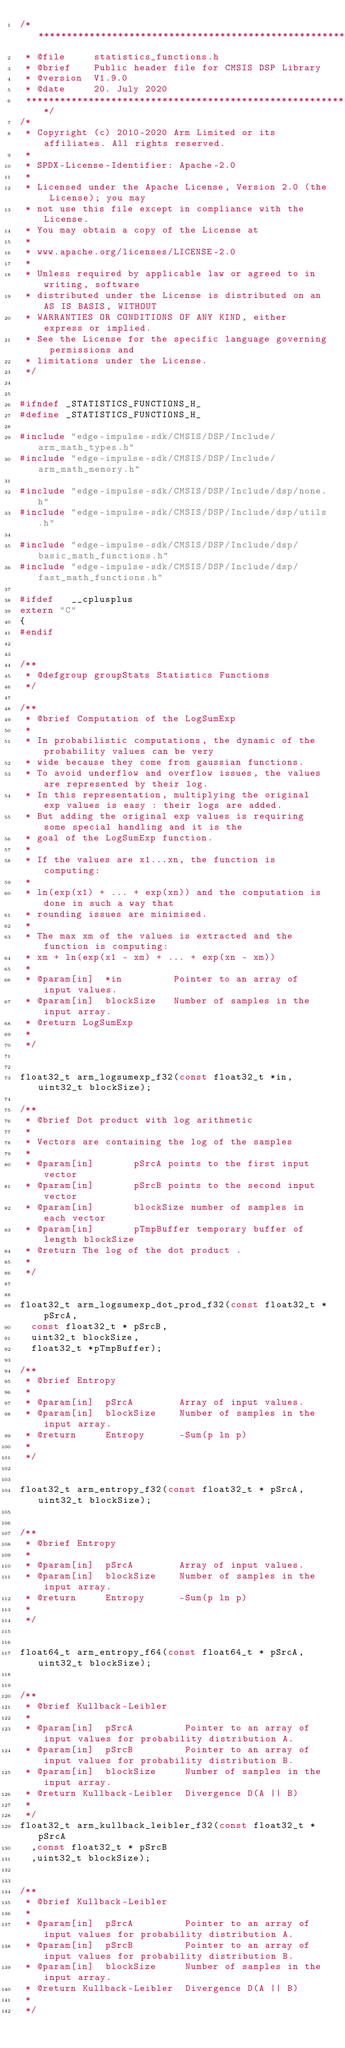Convert code to text. <code><loc_0><loc_0><loc_500><loc_500><_C_>/******************************************************************************
 * @file     statistics_functions.h
 * @brief    Public header file for CMSIS DSP Library
 * @version  V1.9.0
 * @date     20. July 2020
 ******************************************************************************/
/*
 * Copyright (c) 2010-2020 Arm Limited or its affiliates. All rights reserved.
 *
 * SPDX-License-Identifier: Apache-2.0
 *
 * Licensed under the Apache License, Version 2.0 (the License); you may
 * not use this file except in compliance with the License.
 * You may obtain a copy of the License at
 *
 * www.apache.org/licenses/LICENSE-2.0
 *
 * Unless required by applicable law or agreed to in writing, software
 * distributed under the License is distributed on an AS IS BASIS, WITHOUT
 * WARRANTIES OR CONDITIONS OF ANY KIND, either express or implied.
 * See the License for the specific language governing permissions and
 * limitations under the License.
 */

 
#ifndef _STATISTICS_FUNCTIONS_H_
#define _STATISTICS_FUNCTIONS_H_

#include "edge-impulse-sdk/CMSIS/DSP/Include/arm_math_types.h"
#include "edge-impulse-sdk/CMSIS/DSP/Include/arm_math_memory.h"

#include "edge-impulse-sdk/CMSIS/DSP/Include/dsp/none.h"
#include "edge-impulse-sdk/CMSIS/DSP/Include/dsp/utils.h"

#include "edge-impulse-sdk/CMSIS/DSP/Include/dsp/basic_math_functions.h"
#include "edge-impulse-sdk/CMSIS/DSP/Include/dsp/fast_math_functions.h"

#ifdef   __cplusplus
extern "C"
{
#endif


/**
 * @defgroup groupStats Statistics Functions
 */

/**
 * @brief Computation of the LogSumExp
 *
 * In probabilistic computations, the dynamic of the probability values can be very
 * wide because they come from gaussian functions.
 * To avoid underflow and overflow issues, the values are represented by their log.
 * In this representation, multiplying the original exp values is easy : their logs are added.
 * But adding the original exp values is requiring some special handling and it is the
 * goal of the LogSumExp function.
 *
 * If the values are x1...xn, the function is computing:
 *
 * ln(exp(x1) + ... + exp(xn)) and the computation is done in such a way that
 * rounding issues are minimised.
 *
 * The max xm of the values is extracted and the function is computing:
 * xm + ln(exp(x1 - xm) + ... + exp(xn - xm))
 *
 * @param[in]  *in         Pointer to an array of input values.
 * @param[in]  blockSize   Number of samples in the input array.
 * @return LogSumExp
 *
 */


float32_t arm_logsumexp_f32(const float32_t *in, uint32_t blockSize);

/**
 * @brief Dot product with log arithmetic
 *
 * Vectors are containing the log of the samples
 *
 * @param[in]       pSrcA points to the first input vector
 * @param[in]       pSrcB points to the second input vector
 * @param[in]       blockSize number of samples in each vector
 * @param[in]       pTmpBuffer temporary buffer of length blockSize
 * @return The log of the dot product .
 *
 */


float32_t arm_logsumexp_dot_prod_f32(const float32_t * pSrcA,
  const float32_t * pSrcB,
  uint32_t blockSize,
  float32_t *pTmpBuffer);

/**
 * @brief Entropy
 *
 * @param[in]  pSrcA        Array of input values.
 * @param[in]  blockSize    Number of samples in the input array.
 * @return     Entropy      -Sum(p ln p)
 *
 */


float32_t arm_entropy_f32(const float32_t * pSrcA,uint32_t blockSize);


/**
 * @brief Entropy
 *
 * @param[in]  pSrcA        Array of input values.
 * @param[in]  blockSize    Number of samples in the input array.
 * @return     Entropy      -Sum(p ln p)
 *
 */


float64_t arm_entropy_f64(const float64_t * pSrcA, uint32_t blockSize);


/**
 * @brief Kullback-Leibler
 *
 * @param[in]  pSrcA         Pointer to an array of input values for probability distribution A.
 * @param[in]  pSrcB         Pointer to an array of input values for probability distribution B.
 * @param[in]  blockSize     Number of samples in the input array.
 * @return Kullback-Leibler  Divergence D(A || B)
 *
 */
float32_t arm_kullback_leibler_f32(const float32_t * pSrcA
  ,const float32_t * pSrcB
  ,uint32_t blockSize);


/**
 * @brief Kullback-Leibler
 *
 * @param[in]  pSrcA         Pointer to an array of input values for probability distribution A.
 * @param[in]  pSrcB         Pointer to an array of input values for probability distribution B.
 * @param[in]  blockSize     Number of samples in the input array.
 * @return Kullback-Leibler  Divergence D(A || B)
 *
 */</code> 